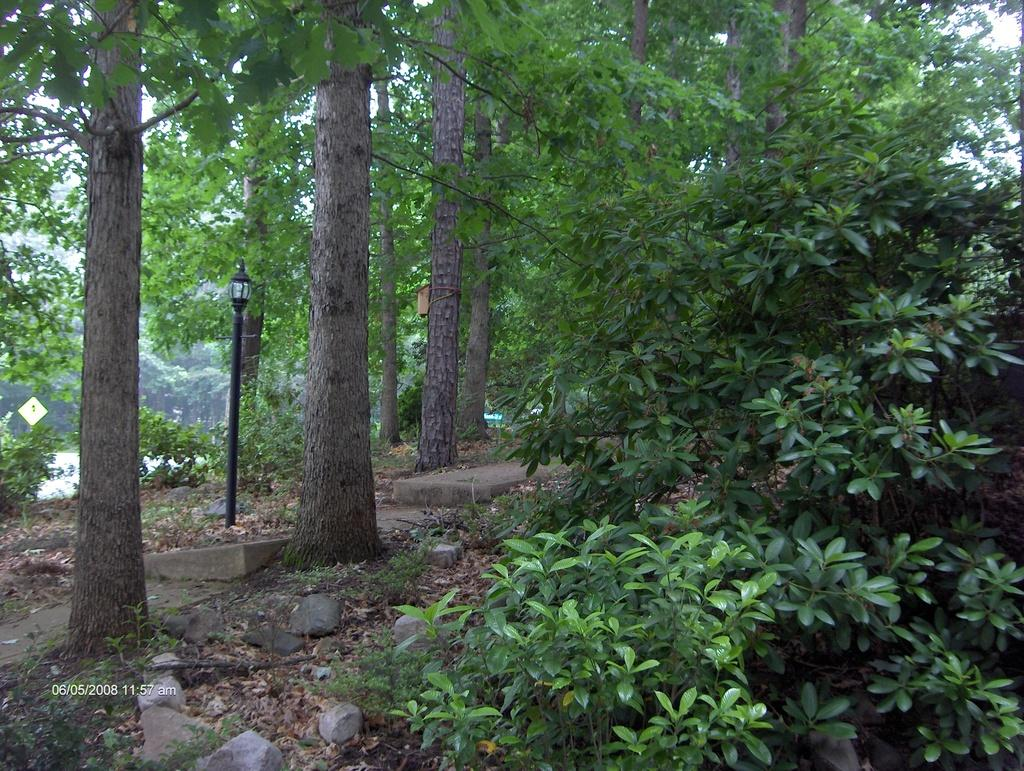What type of natural elements can be seen in the image? There are stones, plants, leaves, and trees visible in the image. What objects are present on the ground in the image? There are objects on the ground in the image. What type of artificial light source is visible in the image? There is a street light in the image. What can be seen in the background of the image? There are trees and the sky visible in the background of the image. Can you describe the wilderness area in the image? There is no wilderness area present in the image; it features a combination of natural and artificial elements. What type of seashore can be seen in the image? There is no seashore present in the image; it does not depict a coastal environment. 